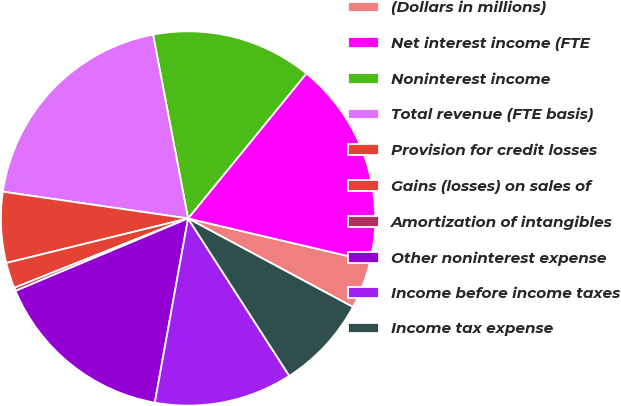Convert chart. <chart><loc_0><loc_0><loc_500><loc_500><pie_chart><fcel>(Dollars in millions)<fcel>Net interest income (FTE<fcel>Noninterest income<fcel>Total revenue (FTE basis)<fcel>Provision for credit losses<fcel>Gains (losses) on sales of<fcel>Amortization of intangibles<fcel>Other noninterest expense<fcel>Income before income taxes<fcel>Income tax expense<nl><fcel>4.17%<fcel>17.78%<fcel>13.89%<fcel>19.72%<fcel>6.11%<fcel>2.22%<fcel>0.28%<fcel>15.83%<fcel>11.94%<fcel>8.06%<nl></chart> 